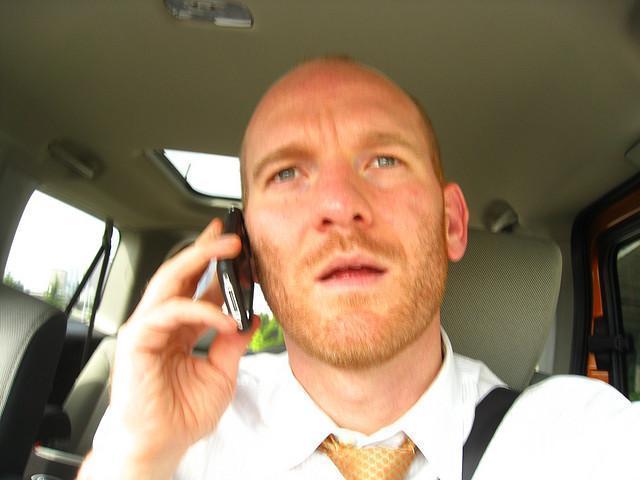How many cell phones can be seen?
Give a very brief answer. 1. 